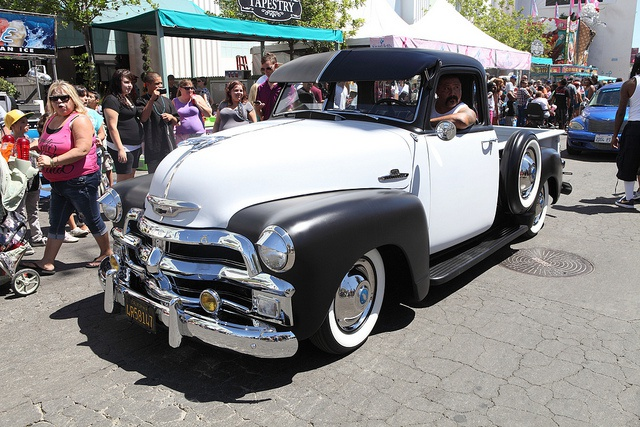Describe the objects in this image and their specific colors. I can see truck in black, white, gray, and darkgray tones, people in black, gray, lightgray, and maroon tones, people in black, maroon, lightpink, and gray tones, people in black, gray, maroon, and tan tones, and people in black, darkgray, and gray tones in this image. 